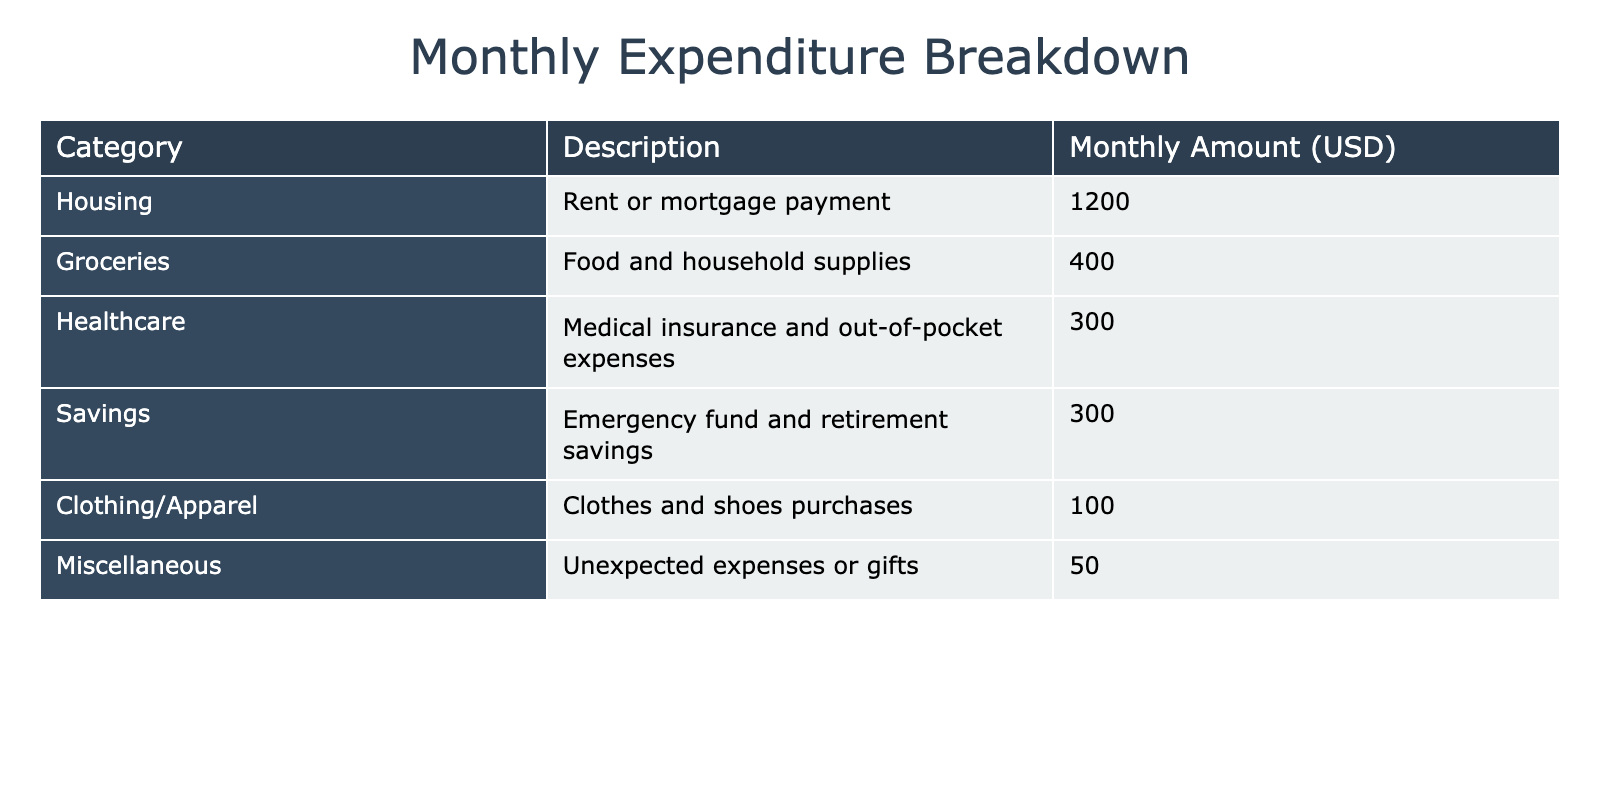What is the total monthly spending on healthcare? The table shows that the amount allocated for healthcare is listed as 300 USD. Therefore, the total monthly spending on healthcare is simply that value.
Answer: 300 USD What is the monthly expenditure for clothing/apparel? The table indicates that the expenditure for clothing/apparel is 100 USD. This value is directly provided in the relevant row of the table.
Answer: 100 USD Is the amount spent on groceries greater than the amount spent on miscellaneous expenses? The amount spent on groceries is 400 USD, and the miscellaneous expenses amount to 50 USD. Since 400 is greater than 50, the answer is yes.
Answer: Yes What is the total monthly expenditure on housing and savings combined? The housing expenditure is 1200 USD, and savings is 300 USD. Adding these two amounts gives 1200 + 300 = 1500 USD, making that the total combined expenditure.
Answer: 1500 USD What percentage of the total monthly expenditure is allocated to groceries? The total monthly expenditure can be calculated by adding all categories: 1200 + 400 + 300 + 300 + 100 + 50 = 2350 USD. Groceries are 400 USD, so the percentage is (400 / 2350) * 100 ≈ 17.02%. Hence, groceries make up about 17.02% of the total expenditure.
Answer: 17.02% What is the difference between the housing expenditure and the total spent on healthcare and clothing/apparel? Housing expenditure is 1200 USD. The total for healthcare and clothing/apparel is 300 + 100 = 400 USD. The difference is 1200 - 400 = 800 USD, showing a significant difference between these spending categories.
Answer: 800 USD How much more is spent on savings compared to miscellaneous expenses? The savings amount is 300 USD, while miscellaneous expenses total 50 USD. The difference can be found by subtracting: 300 - 50 = 250 USD, indicating a notable amount spent on savings compared to miscellaneous expenses.
Answer: 250 USD Is the total expenditure on groceries less than 500 USD? The table lists grocery spending as 400 USD, which is indeed less than 500 USD. Therefore, the answer to this question is yes.
Answer: Yes What is the average monthly expenditure across all categories? To find the average, we need to sum all expenditures: 1200 + 400 + 300 + 300 + 100 + 50 = 2350 USD. There are 6 categories, thus the average is 2350 / 6 ≈ 391.67 USD. Therefore, the average monthly expenditure is about 391.67 USD per category.
Answer: 391.67 USD 